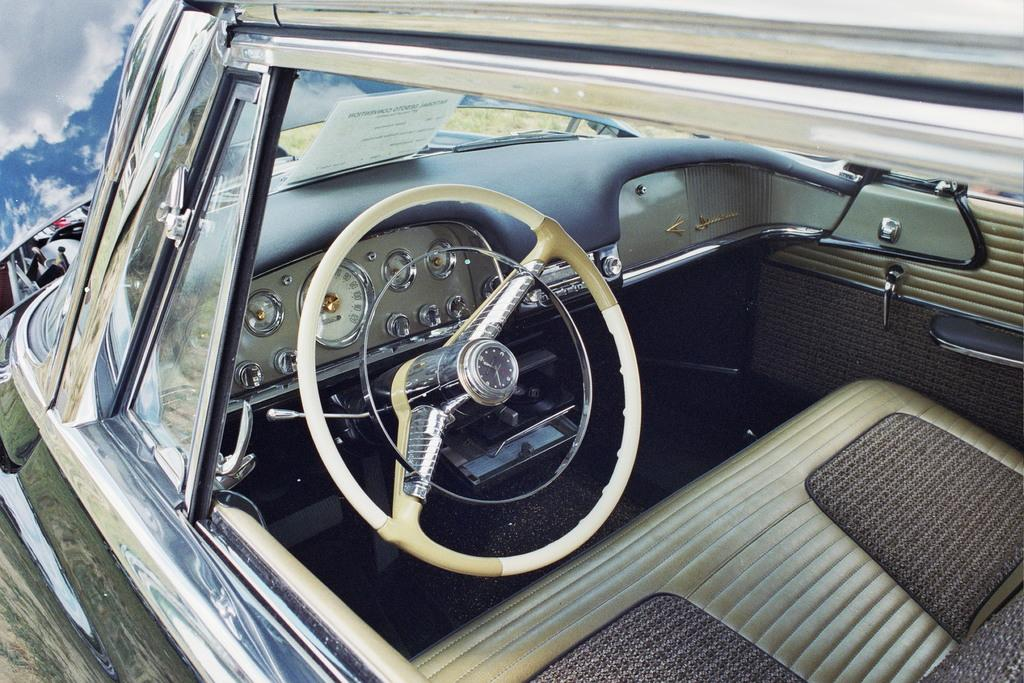What is the main subject of the image? There is a vehicle in the image. What feature is present inside the vehicle? The vehicle has a steering wheel. What can be seen in the background of the image? There is a sky visible in the background of the image. What is the condition of the sky in the image? Clouds are present in the sky. What type of rhythm can be heard coming from the vehicle in the image? There is no indication of sound or rhythm in the image, as it only shows a vehicle with a steering wheel and a sky with clouds. 